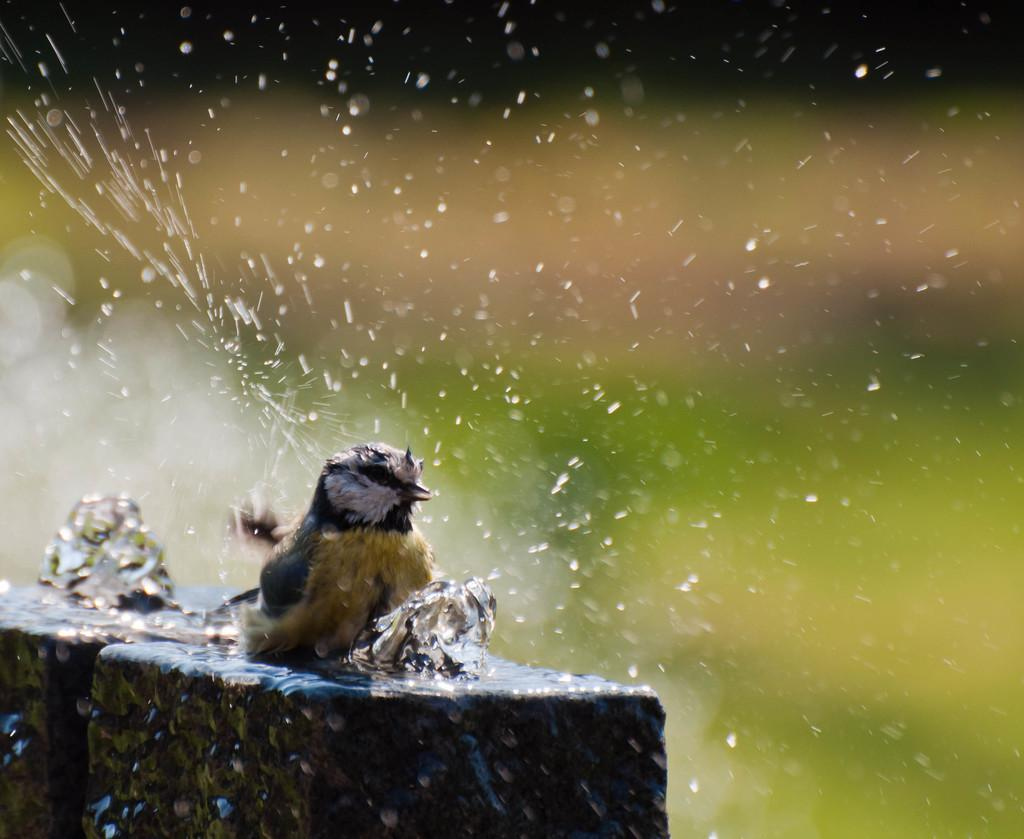What type of animal can be seen in the image? There is a bird in the image. What is the primary element in which the bird is situated? There is water visible in the image, and the bird is likely situated in or near it. How many toes can be seen on the bird's feet in the image? There is no information about the bird's toes in the image, so it cannot be determined from the image. 